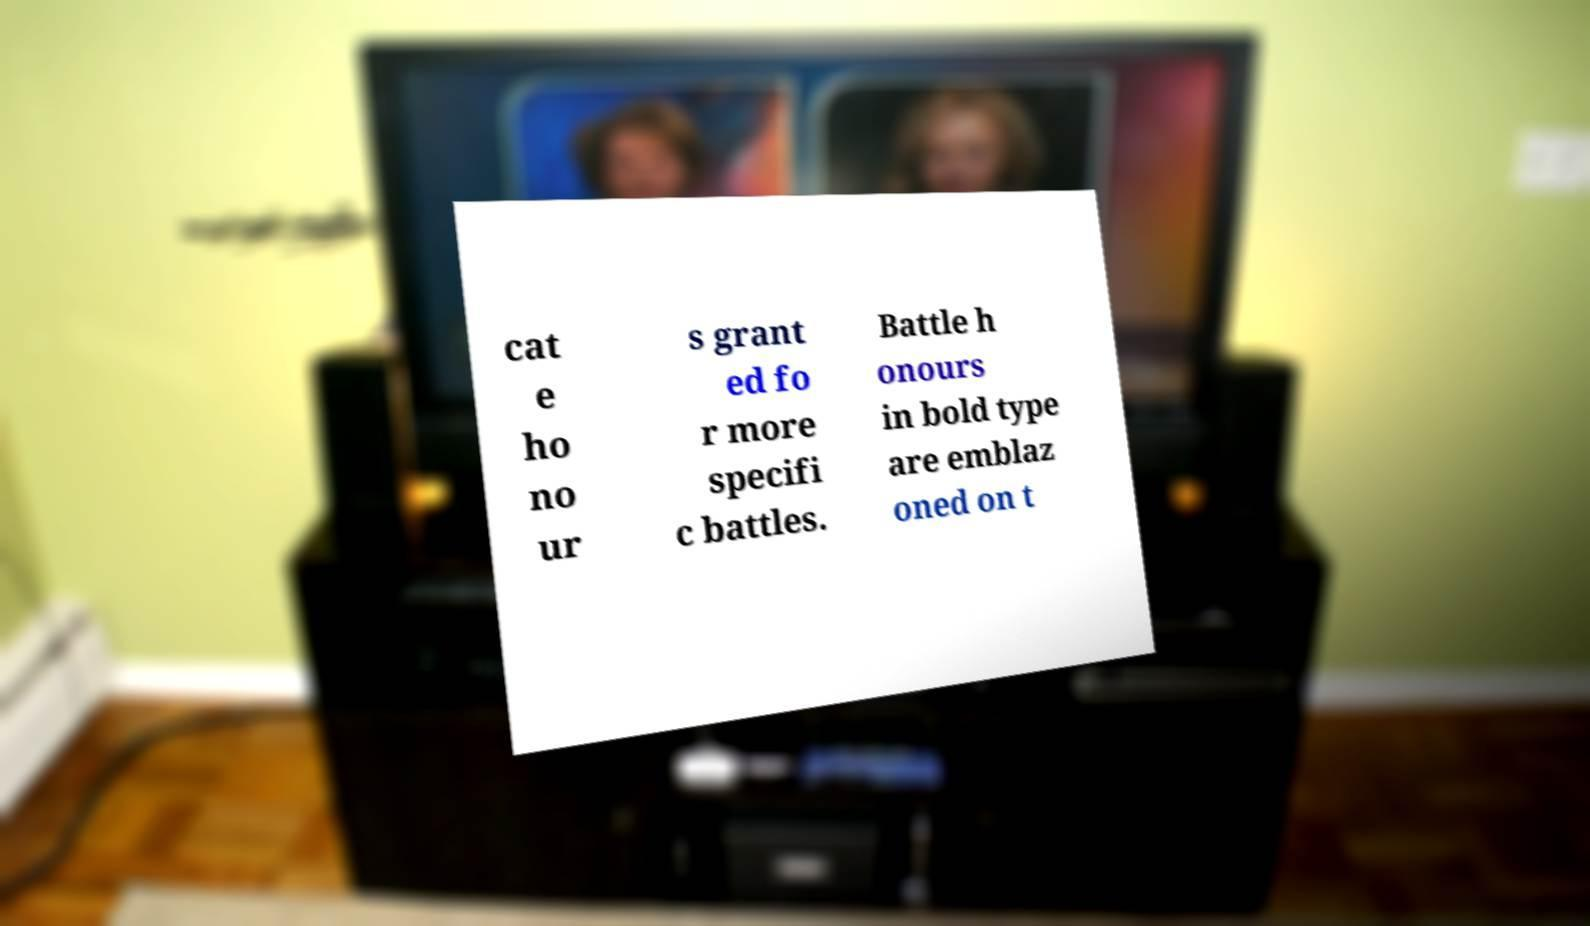Please read and relay the text visible in this image. What does it say? cat e ho no ur s grant ed fo r more specifi c battles. Battle h onours in bold type are emblaz oned on t 